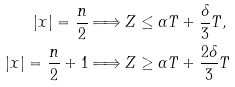<formula> <loc_0><loc_0><loc_500><loc_500>\left | x \right | = \frac { n } { 2 } & \Longrightarrow Z \leq \alpha T + \frac { \delta } { 3 } T , \\ \left | x \right | = \frac { n } { 2 } + 1 & \Longrightarrow Z \geq \alpha T + \frac { 2 \delta } { 3 } T</formula> 